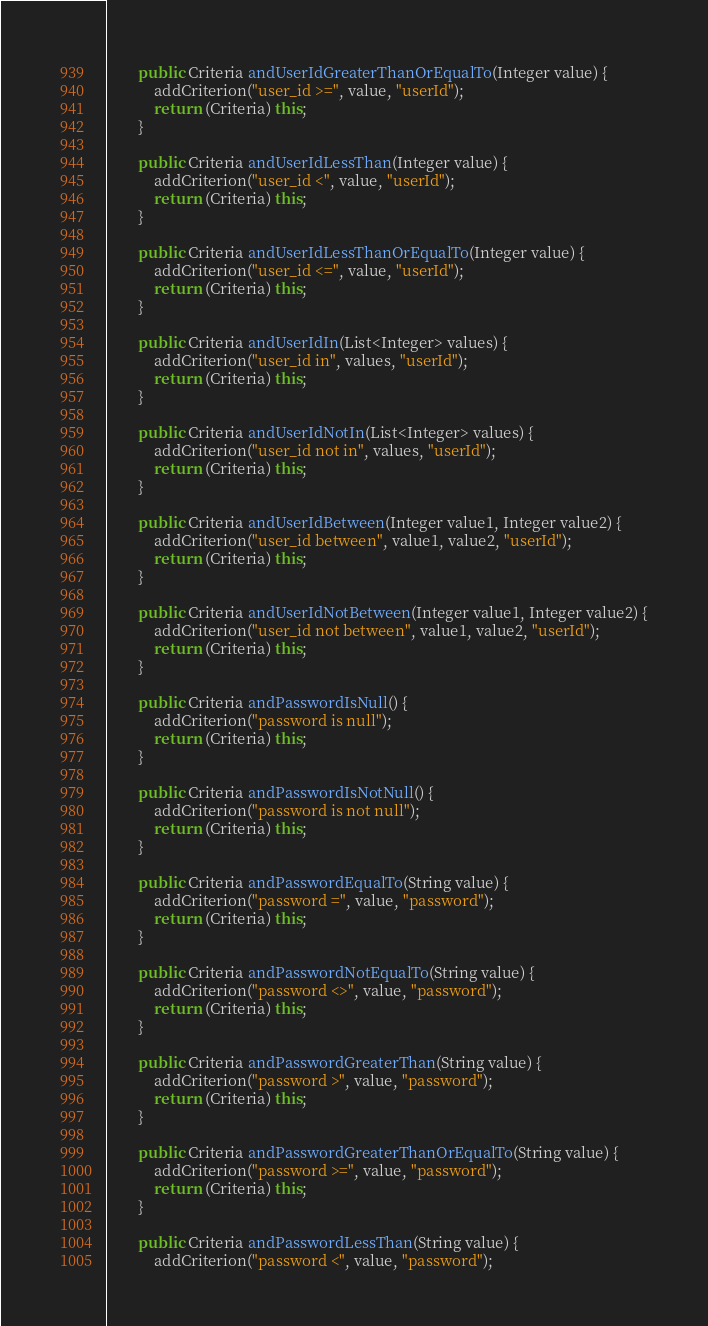<code> <loc_0><loc_0><loc_500><loc_500><_Java_>        public Criteria andUserIdGreaterThanOrEqualTo(Integer value) {
            addCriterion("user_id >=", value, "userId");
            return (Criteria) this;
        }

        public Criteria andUserIdLessThan(Integer value) {
            addCriterion("user_id <", value, "userId");
            return (Criteria) this;
        }

        public Criteria andUserIdLessThanOrEqualTo(Integer value) {
            addCriterion("user_id <=", value, "userId");
            return (Criteria) this;
        }

        public Criteria andUserIdIn(List<Integer> values) {
            addCriterion("user_id in", values, "userId");
            return (Criteria) this;
        }

        public Criteria andUserIdNotIn(List<Integer> values) {
            addCriterion("user_id not in", values, "userId");
            return (Criteria) this;
        }

        public Criteria andUserIdBetween(Integer value1, Integer value2) {
            addCriterion("user_id between", value1, value2, "userId");
            return (Criteria) this;
        }

        public Criteria andUserIdNotBetween(Integer value1, Integer value2) {
            addCriterion("user_id not between", value1, value2, "userId");
            return (Criteria) this;
        }

        public Criteria andPasswordIsNull() {
            addCriterion("password is null");
            return (Criteria) this;
        }

        public Criteria andPasswordIsNotNull() {
            addCriterion("password is not null");
            return (Criteria) this;
        }

        public Criteria andPasswordEqualTo(String value) {
            addCriterion("password =", value, "password");
            return (Criteria) this;
        }

        public Criteria andPasswordNotEqualTo(String value) {
            addCriterion("password <>", value, "password");
            return (Criteria) this;
        }

        public Criteria andPasswordGreaterThan(String value) {
            addCriterion("password >", value, "password");
            return (Criteria) this;
        }

        public Criteria andPasswordGreaterThanOrEqualTo(String value) {
            addCriterion("password >=", value, "password");
            return (Criteria) this;
        }

        public Criteria andPasswordLessThan(String value) {
            addCriterion("password <", value, "password");</code> 